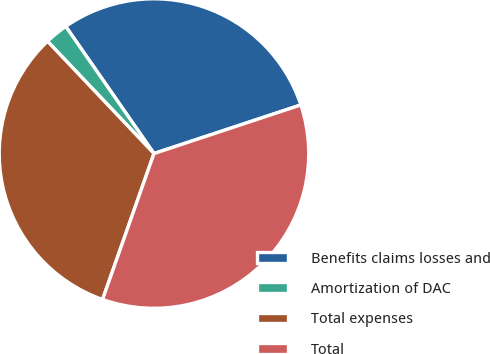Convert chart. <chart><loc_0><loc_0><loc_500><loc_500><pie_chart><fcel>Benefits claims losses and<fcel>Amortization of DAC<fcel>Total expenses<fcel>Total<nl><fcel>29.57%<fcel>2.42%<fcel>32.53%<fcel>35.48%<nl></chart> 